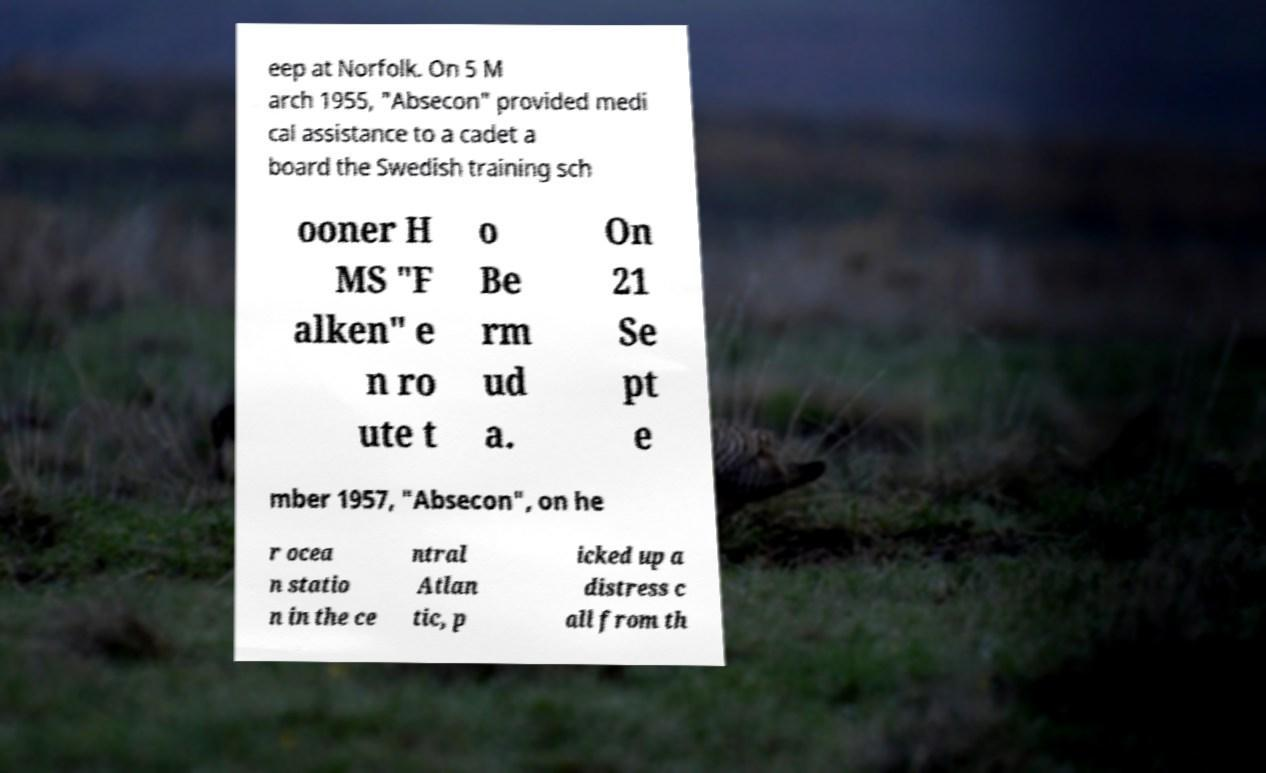Could you extract and type out the text from this image? eep at Norfolk. On 5 M arch 1955, "Absecon" provided medi cal assistance to a cadet a board the Swedish training sch ooner H MS "F alken" e n ro ute t o Be rm ud a. On 21 Se pt e mber 1957, "Absecon", on he r ocea n statio n in the ce ntral Atlan tic, p icked up a distress c all from th 